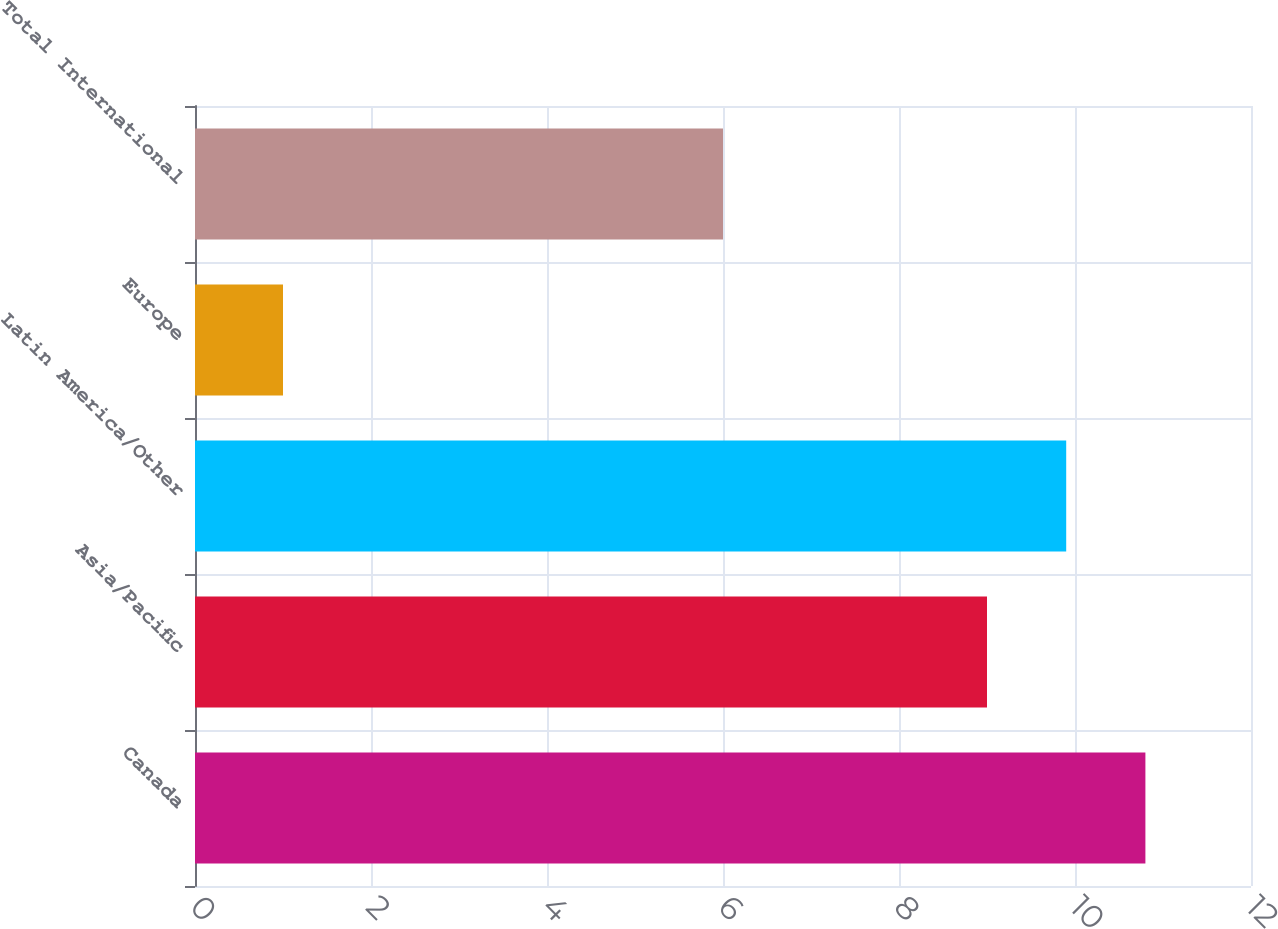<chart> <loc_0><loc_0><loc_500><loc_500><bar_chart><fcel>Canada<fcel>Asia/Pacific<fcel>Latin America/Other<fcel>Europe<fcel>Total International<nl><fcel>10.8<fcel>9<fcel>9.9<fcel>1<fcel>6<nl></chart> 